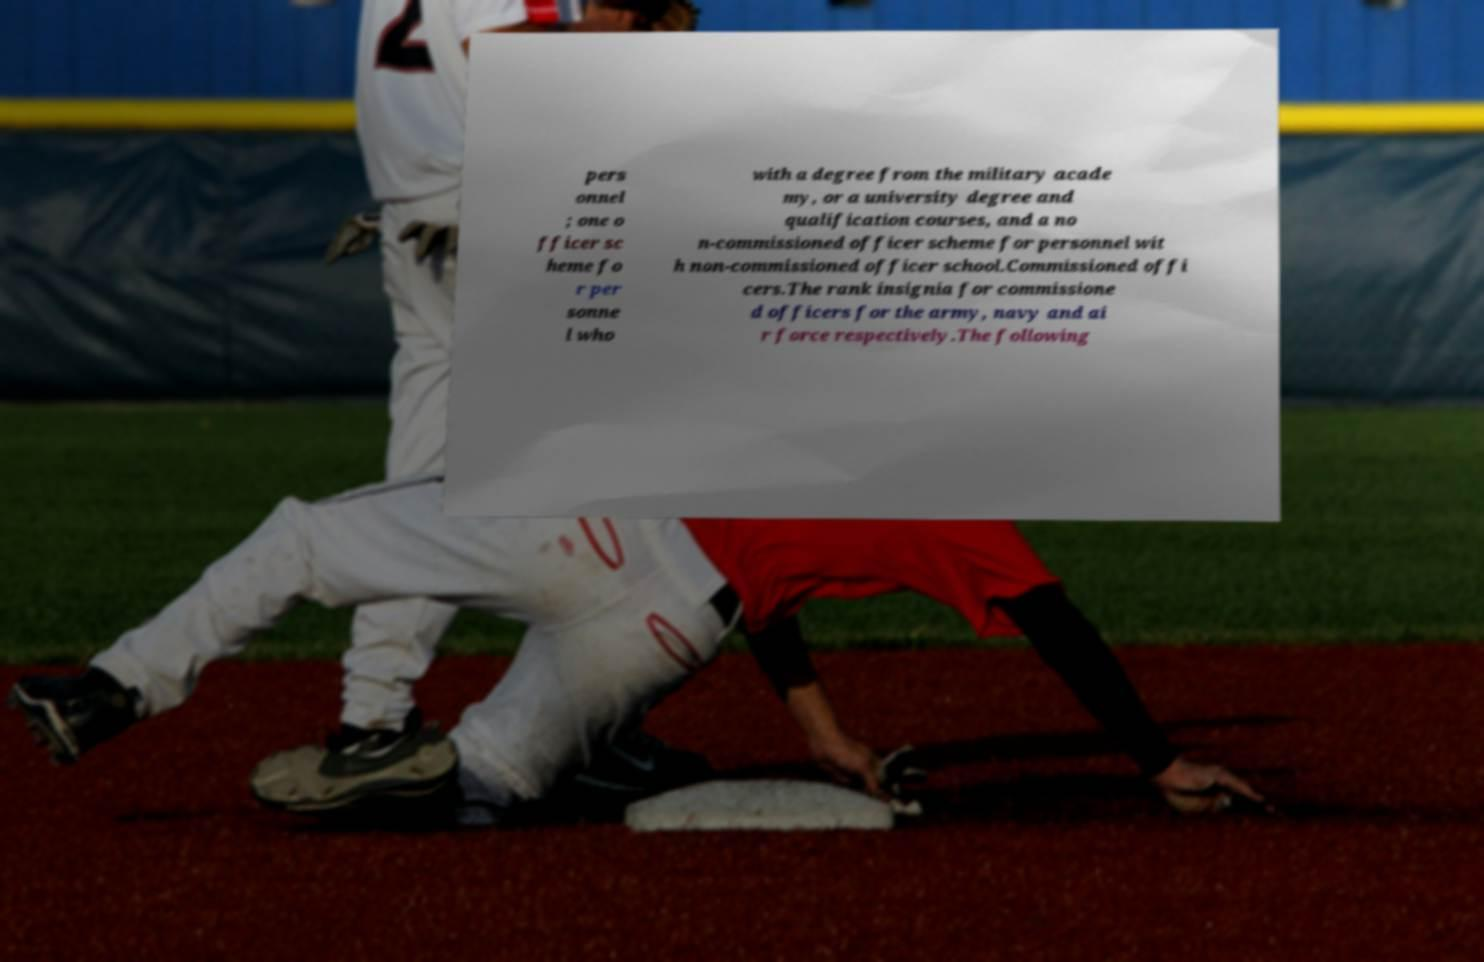Could you assist in decoding the text presented in this image and type it out clearly? pers onnel ; one o fficer sc heme fo r per sonne l who with a degree from the military acade my, or a university degree and qualification courses, and a no n-commissioned officer scheme for personnel wit h non-commissioned officer school.Commissioned offi cers.The rank insignia for commissione d officers for the army, navy and ai r force respectively.The following 